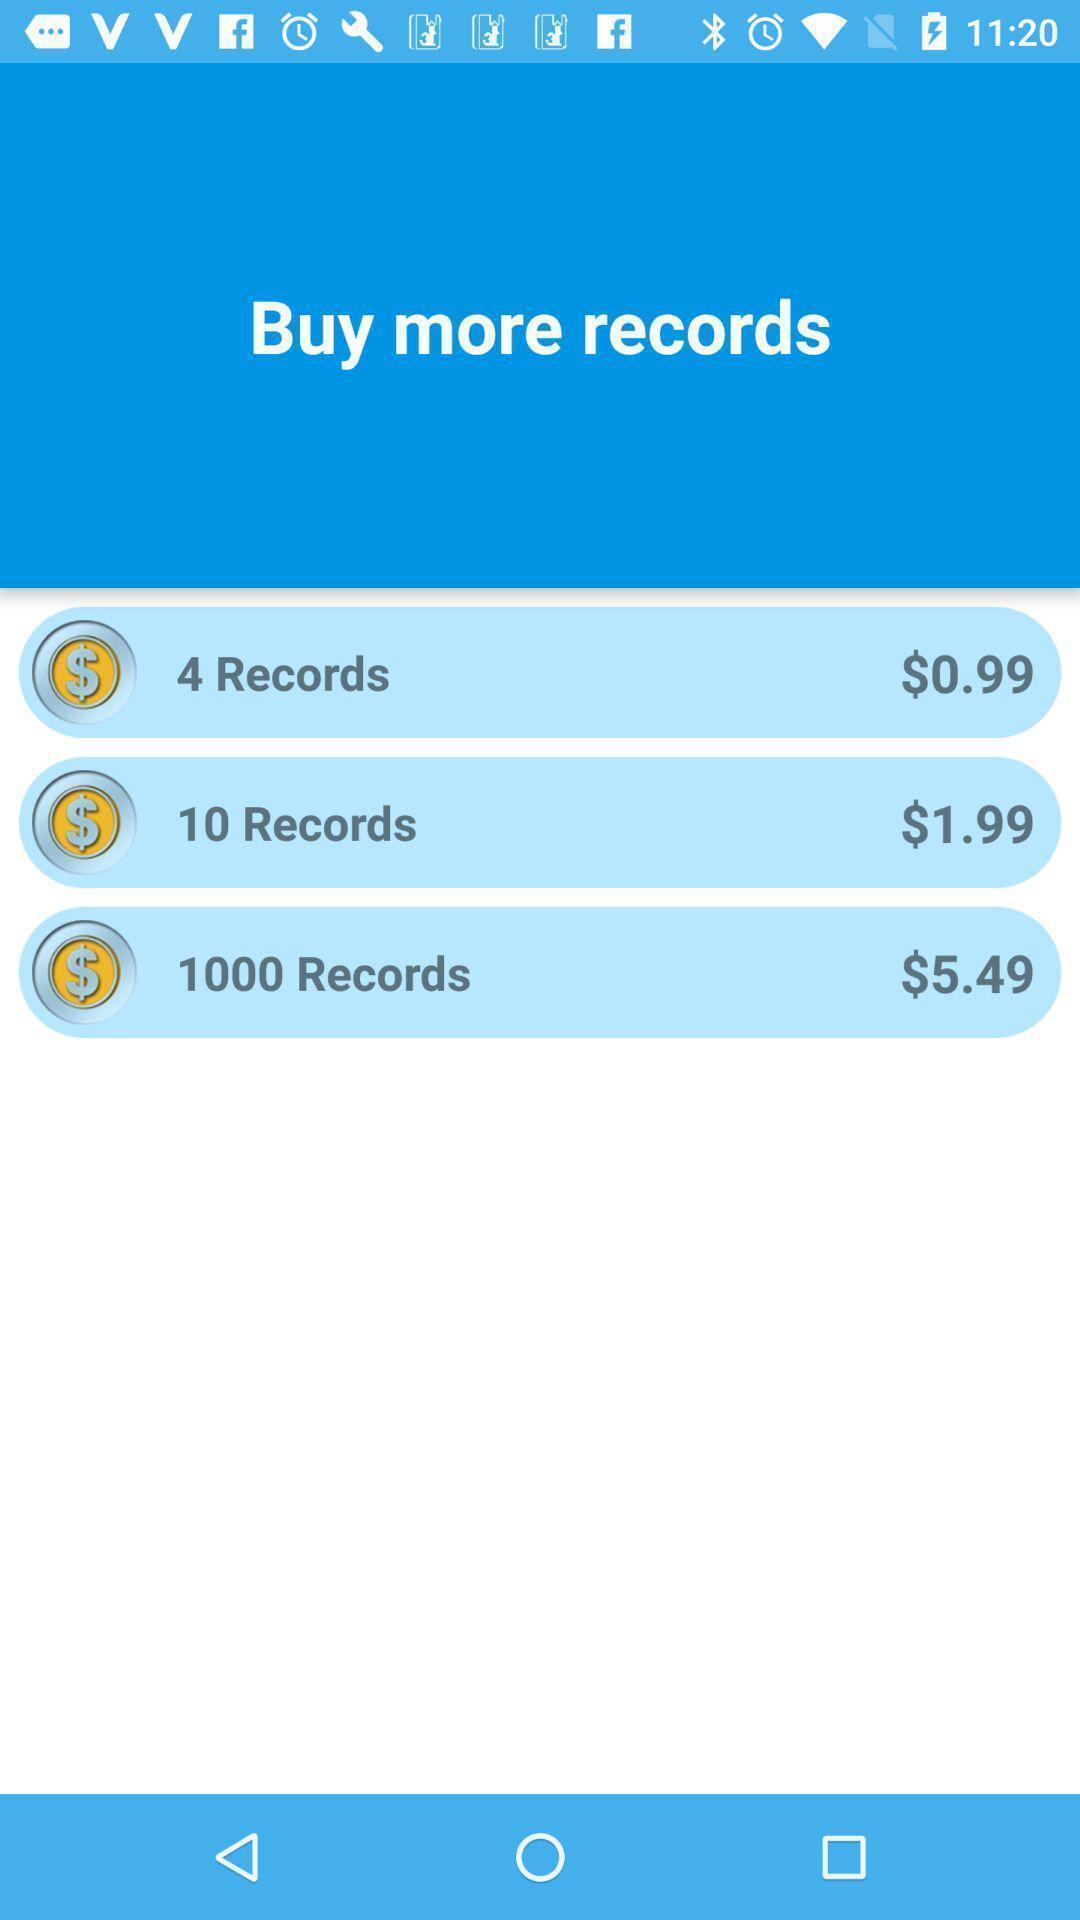Give me a summary of this screen capture. List of records to buy in the application. 